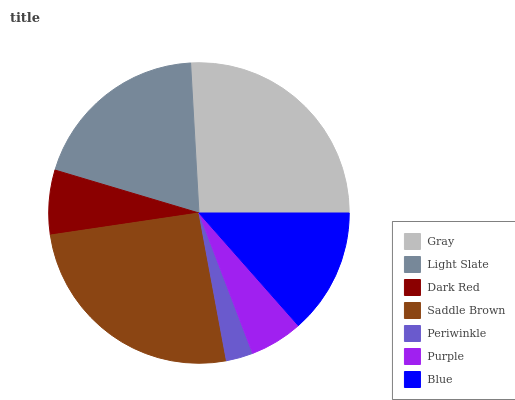Is Periwinkle the minimum?
Answer yes or no. Yes. Is Gray the maximum?
Answer yes or no. Yes. Is Light Slate the minimum?
Answer yes or no. No. Is Light Slate the maximum?
Answer yes or no. No. Is Gray greater than Light Slate?
Answer yes or no. Yes. Is Light Slate less than Gray?
Answer yes or no. Yes. Is Light Slate greater than Gray?
Answer yes or no. No. Is Gray less than Light Slate?
Answer yes or no. No. Is Blue the high median?
Answer yes or no. Yes. Is Blue the low median?
Answer yes or no. Yes. Is Dark Red the high median?
Answer yes or no. No. Is Periwinkle the low median?
Answer yes or no. No. 